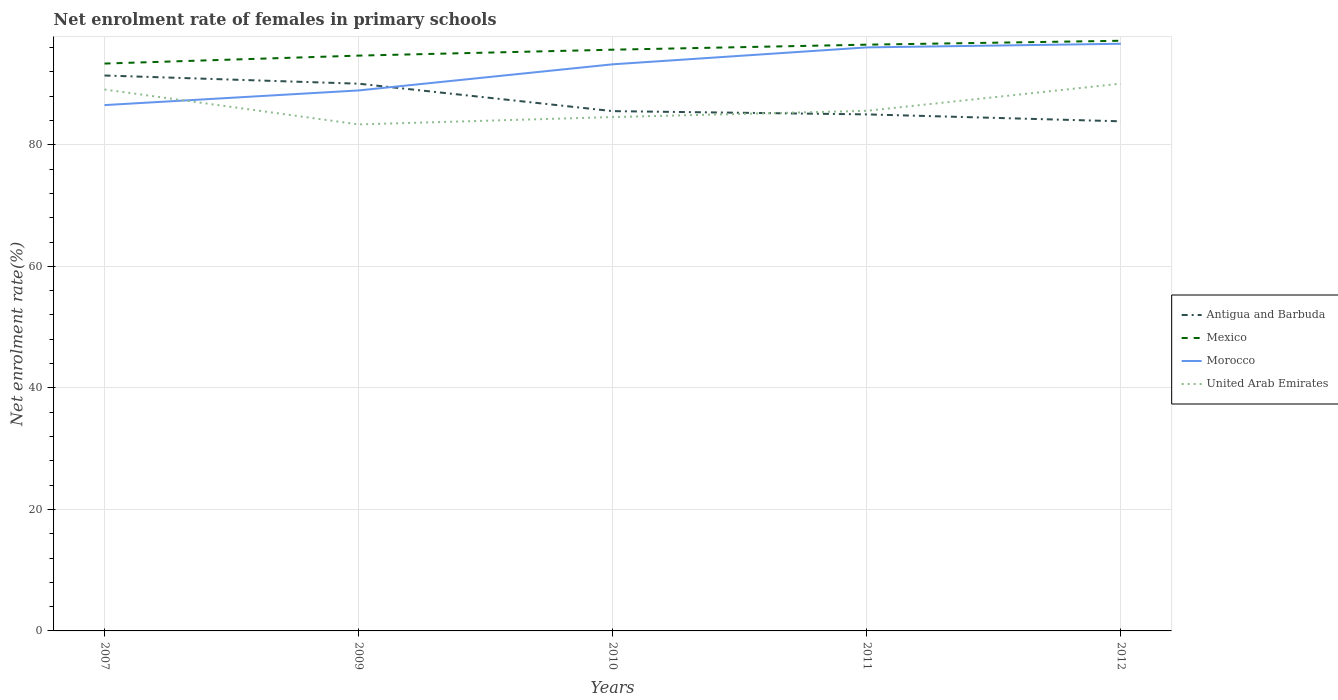How many different coloured lines are there?
Make the answer very short. 4. Does the line corresponding to Morocco intersect with the line corresponding to Mexico?
Keep it short and to the point. No. Is the number of lines equal to the number of legend labels?
Offer a terse response. Yes. Across all years, what is the maximum net enrolment rate of females in primary schools in Antigua and Barbuda?
Give a very brief answer. 83.87. In which year was the net enrolment rate of females in primary schools in United Arab Emirates maximum?
Provide a succinct answer. 2009. What is the total net enrolment rate of females in primary schools in Morocco in the graph?
Your response must be concise. -3.38. What is the difference between the highest and the second highest net enrolment rate of females in primary schools in Morocco?
Your response must be concise. 10.09. What is the difference between the highest and the lowest net enrolment rate of females in primary schools in Morocco?
Provide a short and direct response. 3. Is the net enrolment rate of females in primary schools in Mexico strictly greater than the net enrolment rate of females in primary schools in Antigua and Barbuda over the years?
Offer a terse response. No. How many lines are there?
Keep it short and to the point. 4. How many years are there in the graph?
Your answer should be compact. 5. What is the difference between two consecutive major ticks on the Y-axis?
Give a very brief answer. 20. Are the values on the major ticks of Y-axis written in scientific E-notation?
Your response must be concise. No. Does the graph contain grids?
Your answer should be very brief. Yes. Where does the legend appear in the graph?
Provide a short and direct response. Center right. How many legend labels are there?
Offer a terse response. 4. What is the title of the graph?
Your answer should be compact. Net enrolment rate of females in primary schools. Does "Serbia" appear as one of the legend labels in the graph?
Ensure brevity in your answer.  No. What is the label or title of the Y-axis?
Ensure brevity in your answer.  Net enrolment rate(%). What is the Net enrolment rate(%) in Antigua and Barbuda in 2007?
Provide a succinct answer. 91.42. What is the Net enrolment rate(%) of Mexico in 2007?
Provide a succinct answer. 93.38. What is the Net enrolment rate(%) in Morocco in 2007?
Keep it short and to the point. 86.54. What is the Net enrolment rate(%) of United Arab Emirates in 2007?
Give a very brief answer. 89.11. What is the Net enrolment rate(%) in Antigua and Barbuda in 2009?
Provide a short and direct response. 90.07. What is the Net enrolment rate(%) of Mexico in 2009?
Offer a very short reply. 94.69. What is the Net enrolment rate(%) of Morocco in 2009?
Your answer should be compact. 88.96. What is the Net enrolment rate(%) in United Arab Emirates in 2009?
Provide a succinct answer. 83.37. What is the Net enrolment rate(%) in Antigua and Barbuda in 2010?
Provide a succinct answer. 85.55. What is the Net enrolment rate(%) in Mexico in 2010?
Make the answer very short. 95.66. What is the Net enrolment rate(%) in Morocco in 2010?
Make the answer very short. 93.26. What is the Net enrolment rate(%) in United Arab Emirates in 2010?
Offer a very short reply. 84.57. What is the Net enrolment rate(%) of Antigua and Barbuda in 2011?
Provide a succinct answer. 85.01. What is the Net enrolment rate(%) in Mexico in 2011?
Provide a short and direct response. 96.49. What is the Net enrolment rate(%) in Morocco in 2011?
Make the answer very short. 96.04. What is the Net enrolment rate(%) of United Arab Emirates in 2011?
Your answer should be compact. 85.6. What is the Net enrolment rate(%) of Antigua and Barbuda in 2012?
Keep it short and to the point. 83.87. What is the Net enrolment rate(%) of Mexico in 2012?
Offer a terse response. 97.13. What is the Net enrolment rate(%) in Morocco in 2012?
Your answer should be very brief. 96.64. What is the Net enrolment rate(%) in United Arab Emirates in 2012?
Your answer should be very brief. 90.07. Across all years, what is the maximum Net enrolment rate(%) in Antigua and Barbuda?
Keep it short and to the point. 91.42. Across all years, what is the maximum Net enrolment rate(%) in Mexico?
Ensure brevity in your answer.  97.13. Across all years, what is the maximum Net enrolment rate(%) in Morocco?
Keep it short and to the point. 96.64. Across all years, what is the maximum Net enrolment rate(%) of United Arab Emirates?
Your response must be concise. 90.07. Across all years, what is the minimum Net enrolment rate(%) of Antigua and Barbuda?
Offer a terse response. 83.87. Across all years, what is the minimum Net enrolment rate(%) of Mexico?
Your answer should be compact. 93.38. Across all years, what is the minimum Net enrolment rate(%) of Morocco?
Your response must be concise. 86.54. Across all years, what is the minimum Net enrolment rate(%) of United Arab Emirates?
Your answer should be compact. 83.37. What is the total Net enrolment rate(%) in Antigua and Barbuda in the graph?
Provide a succinct answer. 435.92. What is the total Net enrolment rate(%) in Mexico in the graph?
Keep it short and to the point. 477.35. What is the total Net enrolment rate(%) in Morocco in the graph?
Make the answer very short. 461.43. What is the total Net enrolment rate(%) of United Arab Emirates in the graph?
Your response must be concise. 432.72. What is the difference between the Net enrolment rate(%) of Antigua and Barbuda in 2007 and that in 2009?
Give a very brief answer. 1.35. What is the difference between the Net enrolment rate(%) in Mexico in 2007 and that in 2009?
Give a very brief answer. -1.31. What is the difference between the Net enrolment rate(%) of Morocco in 2007 and that in 2009?
Give a very brief answer. -2.41. What is the difference between the Net enrolment rate(%) in United Arab Emirates in 2007 and that in 2009?
Your answer should be very brief. 5.74. What is the difference between the Net enrolment rate(%) in Antigua and Barbuda in 2007 and that in 2010?
Give a very brief answer. 5.87. What is the difference between the Net enrolment rate(%) in Mexico in 2007 and that in 2010?
Provide a succinct answer. -2.28. What is the difference between the Net enrolment rate(%) of Morocco in 2007 and that in 2010?
Provide a short and direct response. -6.71. What is the difference between the Net enrolment rate(%) of United Arab Emirates in 2007 and that in 2010?
Offer a very short reply. 4.54. What is the difference between the Net enrolment rate(%) in Antigua and Barbuda in 2007 and that in 2011?
Keep it short and to the point. 6.4. What is the difference between the Net enrolment rate(%) of Mexico in 2007 and that in 2011?
Provide a short and direct response. -3.11. What is the difference between the Net enrolment rate(%) of Morocco in 2007 and that in 2011?
Keep it short and to the point. -9.5. What is the difference between the Net enrolment rate(%) in United Arab Emirates in 2007 and that in 2011?
Offer a terse response. 3.5. What is the difference between the Net enrolment rate(%) in Antigua and Barbuda in 2007 and that in 2012?
Give a very brief answer. 7.54. What is the difference between the Net enrolment rate(%) of Mexico in 2007 and that in 2012?
Provide a short and direct response. -3.75. What is the difference between the Net enrolment rate(%) in Morocco in 2007 and that in 2012?
Ensure brevity in your answer.  -10.09. What is the difference between the Net enrolment rate(%) of United Arab Emirates in 2007 and that in 2012?
Your answer should be compact. -0.96. What is the difference between the Net enrolment rate(%) in Antigua and Barbuda in 2009 and that in 2010?
Provide a short and direct response. 4.52. What is the difference between the Net enrolment rate(%) of Mexico in 2009 and that in 2010?
Provide a succinct answer. -0.97. What is the difference between the Net enrolment rate(%) in United Arab Emirates in 2009 and that in 2010?
Your answer should be very brief. -1.21. What is the difference between the Net enrolment rate(%) in Antigua and Barbuda in 2009 and that in 2011?
Offer a very short reply. 5.05. What is the difference between the Net enrolment rate(%) of Mexico in 2009 and that in 2011?
Offer a terse response. -1.8. What is the difference between the Net enrolment rate(%) of Morocco in 2009 and that in 2011?
Give a very brief answer. -7.09. What is the difference between the Net enrolment rate(%) of United Arab Emirates in 2009 and that in 2011?
Keep it short and to the point. -2.24. What is the difference between the Net enrolment rate(%) in Antigua and Barbuda in 2009 and that in 2012?
Offer a terse response. 6.19. What is the difference between the Net enrolment rate(%) of Mexico in 2009 and that in 2012?
Your answer should be very brief. -2.44. What is the difference between the Net enrolment rate(%) of Morocco in 2009 and that in 2012?
Ensure brevity in your answer.  -7.68. What is the difference between the Net enrolment rate(%) of United Arab Emirates in 2009 and that in 2012?
Offer a terse response. -6.7. What is the difference between the Net enrolment rate(%) in Antigua and Barbuda in 2010 and that in 2011?
Provide a short and direct response. 0.54. What is the difference between the Net enrolment rate(%) in Mexico in 2010 and that in 2011?
Ensure brevity in your answer.  -0.83. What is the difference between the Net enrolment rate(%) in Morocco in 2010 and that in 2011?
Your response must be concise. -2.79. What is the difference between the Net enrolment rate(%) in United Arab Emirates in 2010 and that in 2011?
Your answer should be compact. -1.03. What is the difference between the Net enrolment rate(%) of Antigua and Barbuda in 2010 and that in 2012?
Ensure brevity in your answer.  1.68. What is the difference between the Net enrolment rate(%) in Mexico in 2010 and that in 2012?
Provide a short and direct response. -1.47. What is the difference between the Net enrolment rate(%) of Morocco in 2010 and that in 2012?
Offer a very short reply. -3.38. What is the difference between the Net enrolment rate(%) of United Arab Emirates in 2010 and that in 2012?
Ensure brevity in your answer.  -5.5. What is the difference between the Net enrolment rate(%) in Antigua and Barbuda in 2011 and that in 2012?
Your answer should be very brief. 1.14. What is the difference between the Net enrolment rate(%) in Mexico in 2011 and that in 2012?
Your answer should be very brief. -0.64. What is the difference between the Net enrolment rate(%) of Morocco in 2011 and that in 2012?
Offer a terse response. -0.6. What is the difference between the Net enrolment rate(%) in United Arab Emirates in 2011 and that in 2012?
Ensure brevity in your answer.  -4.47. What is the difference between the Net enrolment rate(%) of Antigua and Barbuda in 2007 and the Net enrolment rate(%) of Mexico in 2009?
Give a very brief answer. -3.27. What is the difference between the Net enrolment rate(%) in Antigua and Barbuda in 2007 and the Net enrolment rate(%) in Morocco in 2009?
Ensure brevity in your answer.  2.46. What is the difference between the Net enrolment rate(%) in Antigua and Barbuda in 2007 and the Net enrolment rate(%) in United Arab Emirates in 2009?
Give a very brief answer. 8.05. What is the difference between the Net enrolment rate(%) in Mexico in 2007 and the Net enrolment rate(%) in Morocco in 2009?
Provide a succinct answer. 4.42. What is the difference between the Net enrolment rate(%) in Mexico in 2007 and the Net enrolment rate(%) in United Arab Emirates in 2009?
Give a very brief answer. 10.01. What is the difference between the Net enrolment rate(%) of Morocco in 2007 and the Net enrolment rate(%) of United Arab Emirates in 2009?
Provide a succinct answer. 3.18. What is the difference between the Net enrolment rate(%) of Antigua and Barbuda in 2007 and the Net enrolment rate(%) of Mexico in 2010?
Provide a short and direct response. -4.25. What is the difference between the Net enrolment rate(%) in Antigua and Barbuda in 2007 and the Net enrolment rate(%) in Morocco in 2010?
Your response must be concise. -1.84. What is the difference between the Net enrolment rate(%) in Antigua and Barbuda in 2007 and the Net enrolment rate(%) in United Arab Emirates in 2010?
Keep it short and to the point. 6.84. What is the difference between the Net enrolment rate(%) in Mexico in 2007 and the Net enrolment rate(%) in Morocco in 2010?
Provide a succinct answer. 0.12. What is the difference between the Net enrolment rate(%) in Mexico in 2007 and the Net enrolment rate(%) in United Arab Emirates in 2010?
Offer a very short reply. 8.81. What is the difference between the Net enrolment rate(%) of Morocco in 2007 and the Net enrolment rate(%) of United Arab Emirates in 2010?
Provide a succinct answer. 1.97. What is the difference between the Net enrolment rate(%) in Antigua and Barbuda in 2007 and the Net enrolment rate(%) in Mexico in 2011?
Offer a very short reply. -5.07. What is the difference between the Net enrolment rate(%) in Antigua and Barbuda in 2007 and the Net enrolment rate(%) in Morocco in 2011?
Provide a short and direct response. -4.63. What is the difference between the Net enrolment rate(%) of Antigua and Barbuda in 2007 and the Net enrolment rate(%) of United Arab Emirates in 2011?
Offer a terse response. 5.81. What is the difference between the Net enrolment rate(%) of Mexico in 2007 and the Net enrolment rate(%) of Morocco in 2011?
Your answer should be very brief. -2.66. What is the difference between the Net enrolment rate(%) of Mexico in 2007 and the Net enrolment rate(%) of United Arab Emirates in 2011?
Your answer should be compact. 7.77. What is the difference between the Net enrolment rate(%) of Morocco in 2007 and the Net enrolment rate(%) of United Arab Emirates in 2011?
Offer a very short reply. 0.94. What is the difference between the Net enrolment rate(%) in Antigua and Barbuda in 2007 and the Net enrolment rate(%) in Mexico in 2012?
Provide a succinct answer. -5.72. What is the difference between the Net enrolment rate(%) of Antigua and Barbuda in 2007 and the Net enrolment rate(%) of Morocco in 2012?
Offer a terse response. -5.22. What is the difference between the Net enrolment rate(%) in Antigua and Barbuda in 2007 and the Net enrolment rate(%) in United Arab Emirates in 2012?
Provide a short and direct response. 1.34. What is the difference between the Net enrolment rate(%) of Mexico in 2007 and the Net enrolment rate(%) of Morocco in 2012?
Make the answer very short. -3.26. What is the difference between the Net enrolment rate(%) of Mexico in 2007 and the Net enrolment rate(%) of United Arab Emirates in 2012?
Make the answer very short. 3.31. What is the difference between the Net enrolment rate(%) of Morocco in 2007 and the Net enrolment rate(%) of United Arab Emirates in 2012?
Your answer should be compact. -3.53. What is the difference between the Net enrolment rate(%) in Antigua and Barbuda in 2009 and the Net enrolment rate(%) in Mexico in 2010?
Keep it short and to the point. -5.6. What is the difference between the Net enrolment rate(%) in Antigua and Barbuda in 2009 and the Net enrolment rate(%) in Morocco in 2010?
Your response must be concise. -3.19. What is the difference between the Net enrolment rate(%) of Antigua and Barbuda in 2009 and the Net enrolment rate(%) of United Arab Emirates in 2010?
Make the answer very short. 5.49. What is the difference between the Net enrolment rate(%) of Mexico in 2009 and the Net enrolment rate(%) of Morocco in 2010?
Ensure brevity in your answer.  1.43. What is the difference between the Net enrolment rate(%) in Mexico in 2009 and the Net enrolment rate(%) in United Arab Emirates in 2010?
Provide a succinct answer. 10.12. What is the difference between the Net enrolment rate(%) in Morocco in 2009 and the Net enrolment rate(%) in United Arab Emirates in 2010?
Your answer should be compact. 4.38. What is the difference between the Net enrolment rate(%) in Antigua and Barbuda in 2009 and the Net enrolment rate(%) in Mexico in 2011?
Provide a succinct answer. -6.42. What is the difference between the Net enrolment rate(%) in Antigua and Barbuda in 2009 and the Net enrolment rate(%) in Morocco in 2011?
Provide a succinct answer. -5.98. What is the difference between the Net enrolment rate(%) in Antigua and Barbuda in 2009 and the Net enrolment rate(%) in United Arab Emirates in 2011?
Your answer should be very brief. 4.46. What is the difference between the Net enrolment rate(%) in Mexico in 2009 and the Net enrolment rate(%) in Morocco in 2011?
Make the answer very short. -1.35. What is the difference between the Net enrolment rate(%) of Mexico in 2009 and the Net enrolment rate(%) of United Arab Emirates in 2011?
Provide a short and direct response. 9.08. What is the difference between the Net enrolment rate(%) of Morocco in 2009 and the Net enrolment rate(%) of United Arab Emirates in 2011?
Provide a short and direct response. 3.35. What is the difference between the Net enrolment rate(%) of Antigua and Barbuda in 2009 and the Net enrolment rate(%) of Mexico in 2012?
Offer a terse response. -7.07. What is the difference between the Net enrolment rate(%) of Antigua and Barbuda in 2009 and the Net enrolment rate(%) of Morocco in 2012?
Keep it short and to the point. -6.57. What is the difference between the Net enrolment rate(%) in Antigua and Barbuda in 2009 and the Net enrolment rate(%) in United Arab Emirates in 2012?
Keep it short and to the point. -0. What is the difference between the Net enrolment rate(%) of Mexico in 2009 and the Net enrolment rate(%) of Morocco in 2012?
Your answer should be compact. -1.95. What is the difference between the Net enrolment rate(%) of Mexico in 2009 and the Net enrolment rate(%) of United Arab Emirates in 2012?
Provide a succinct answer. 4.62. What is the difference between the Net enrolment rate(%) in Morocco in 2009 and the Net enrolment rate(%) in United Arab Emirates in 2012?
Give a very brief answer. -1.11. What is the difference between the Net enrolment rate(%) in Antigua and Barbuda in 2010 and the Net enrolment rate(%) in Mexico in 2011?
Ensure brevity in your answer.  -10.94. What is the difference between the Net enrolment rate(%) of Antigua and Barbuda in 2010 and the Net enrolment rate(%) of Morocco in 2011?
Provide a succinct answer. -10.49. What is the difference between the Net enrolment rate(%) of Antigua and Barbuda in 2010 and the Net enrolment rate(%) of United Arab Emirates in 2011?
Keep it short and to the point. -0.05. What is the difference between the Net enrolment rate(%) in Mexico in 2010 and the Net enrolment rate(%) in Morocco in 2011?
Provide a short and direct response. -0.38. What is the difference between the Net enrolment rate(%) of Mexico in 2010 and the Net enrolment rate(%) of United Arab Emirates in 2011?
Keep it short and to the point. 10.06. What is the difference between the Net enrolment rate(%) in Morocco in 2010 and the Net enrolment rate(%) in United Arab Emirates in 2011?
Provide a succinct answer. 7.65. What is the difference between the Net enrolment rate(%) of Antigua and Barbuda in 2010 and the Net enrolment rate(%) of Mexico in 2012?
Keep it short and to the point. -11.58. What is the difference between the Net enrolment rate(%) of Antigua and Barbuda in 2010 and the Net enrolment rate(%) of Morocco in 2012?
Keep it short and to the point. -11.09. What is the difference between the Net enrolment rate(%) in Antigua and Barbuda in 2010 and the Net enrolment rate(%) in United Arab Emirates in 2012?
Offer a terse response. -4.52. What is the difference between the Net enrolment rate(%) of Mexico in 2010 and the Net enrolment rate(%) of Morocco in 2012?
Offer a terse response. -0.98. What is the difference between the Net enrolment rate(%) of Mexico in 2010 and the Net enrolment rate(%) of United Arab Emirates in 2012?
Keep it short and to the point. 5.59. What is the difference between the Net enrolment rate(%) in Morocco in 2010 and the Net enrolment rate(%) in United Arab Emirates in 2012?
Your answer should be very brief. 3.19. What is the difference between the Net enrolment rate(%) of Antigua and Barbuda in 2011 and the Net enrolment rate(%) of Mexico in 2012?
Your answer should be very brief. -12.12. What is the difference between the Net enrolment rate(%) in Antigua and Barbuda in 2011 and the Net enrolment rate(%) in Morocco in 2012?
Keep it short and to the point. -11.62. What is the difference between the Net enrolment rate(%) in Antigua and Barbuda in 2011 and the Net enrolment rate(%) in United Arab Emirates in 2012?
Your answer should be compact. -5.06. What is the difference between the Net enrolment rate(%) of Mexico in 2011 and the Net enrolment rate(%) of Morocco in 2012?
Your answer should be very brief. -0.15. What is the difference between the Net enrolment rate(%) of Mexico in 2011 and the Net enrolment rate(%) of United Arab Emirates in 2012?
Your response must be concise. 6.42. What is the difference between the Net enrolment rate(%) in Morocco in 2011 and the Net enrolment rate(%) in United Arab Emirates in 2012?
Provide a short and direct response. 5.97. What is the average Net enrolment rate(%) of Antigua and Barbuda per year?
Give a very brief answer. 87.18. What is the average Net enrolment rate(%) in Mexico per year?
Offer a very short reply. 95.47. What is the average Net enrolment rate(%) of Morocco per year?
Keep it short and to the point. 92.29. What is the average Net enrolment rate(%) in United Arab Emirates per year?
Give a very brief answer. 86.54. In the year 2007, what is the difference between the Net enrolment rate(%) of Antigua and Barbuda and Net enrolment rate(%) of Mexico?
Offer a very short reply. -1.96. In the year 2007, what is the difference between the Net enrolment rate(%) in Antigua and Barbuda and Net enrolment rate(%) in Morocco?
Offer a terse response. 4.87. In the year 2007, what is the difference between the Net enrolment rate(%) of Antigua and Barbuda and Net enrolment rate(%) of United Arab Emirates?
Offer a very short reply. 2.31. In the year 2007, what is the difference between the Net enrolment rate(%) of Mexico and Net enrolment rate(%) of Morocco?
Give a very brief answer. 6.83. In the year 2007, what is the difference between the Net enrolment rate(%) of Mexico and Net enrolment rate(%) of United Arab Emirates?
Your answer should be compact. 4.27. In the year 2007, what is the difference between the Net enrolment rate(%) in Morocco and Net enrolment rate(%) in United Arab Emirates?
Your response must be concise. -2.56. In the year 2009, what is the difference between the Net enrolment rate(%) of Antigua and Barbuda and Net enrolment rate(%) of Mexico?
Give a very brief answer. -4.62. In the year 2009, what is the difference between the Net enrolment rate(%) of Antigua and Barbuda and Net enrolment rate(%) of Morocco?
Offer a very short reply. 1.11. In the year 2009, what is the difference between the Net enrolment rate(%) of Antigua and Barbuda and Net enrolment rate(%) of United Arab Emirates?
Your answer should be very brief. 6.7. In the year 2009, what is the difference between the Net enrolment rate(%) of Mexico and Net enrolment rate(%) of Morocco?
Your answer should be compact. 5.73. In the year 2009, what is the difference between the Net enrolment rate(%) of Mexico and Net enrolment rate(%) of United Arab Emirates?
Provide a short and direct response. 11.32. In the year 2009, what is the difference between the Net enrolment rate(%) of Morocco and Net enrolment rate(%) of United Arab Emirates?
Your response must be concise. 5.59. In the year 2010, what is the difference between the Net enrolment rate(%) in Antigua and Barbuda and Net enrolment rate(%) in Mexico?
Offer a very short reply. -10.11. In the year 2010, what is the difference between the Net enrolment rate(%) of Antigua and Barbuda and Net enrolment rate(%) of Morocco?
Keep it short and to the point. -7.71. In the year 2010, what is the difference between the Net enrolment rate(%) in Antigua and Barbuda and Net enrolment rate(%) in United Arab Emirates?
Your response must be concise. 0.98. In the year 2010, what is the difference between the Net enrolment rate(%) in Mexico and Net enrolment rate(%) in Morocco?
Your response must be concise. 2.41. In the year 2010, what is the difference between the Net enrolment rate(%) of Mexico and Net enrolment rate(%) of United Arab Emirates?
Offer a very short reply. 11.09. In the year 2010, what is the difference between the Net enrolment rate(%) of Morocco and Net enrolment rate(%) of United Arab Emirates?
Offer a terse response. 8.68. In the year 2011, what is the difference between the Net enrolment rate(%) in Antigua and Barbuda and Net enrolment rate(%) in Mexico?
Provide a short and direct response. -11.48. In the year 2011, what is the difference between the Net enrolment rate(%) in Antigua and Barbuda and Net enrolment rate(%) in Morocco?
Offer a very short reply. -11.03. In the year 2011, what is the difference between the Net enrolment rate(%) in Antigua and Barbuda and Net enrolment rate(%) in United Arab Emirates?
Provide a succinct answer. -0.59. In the year 2011, what is the difference between the Net enrolment rate(%) of Mexico and Net enrolment rate(%) of Morocco?
Your answer should be very brief. 0.45. In the year 2011, what is the difference between the Net enrolment rate(%) in Mexico and Net enrolment rate(%) in United Arab Emirates?
Your response must be concise. 10.88. In the year 2011, what is the difference between the Net enrolment rate(%) of Morocco and Net enrolment rate(%) of United Arab Emirates?
Provide a succinct answer. 10.44. In the year 2012, what is the difference between the Net enrolment rate(%) of Antigua and Barbuda and Net enrolment rate(%) of Mexico?
Offer a terse response. -13.26. In the year 2012, what is the difference between the Net enrolment rate(%) in Antigua and Barbuda and Net enrolment rate(%) in Morocco?
Your response must be concise. -12.76. In the year 2012, what is the difference between the Net enrolment rate(%) of Antigua and Barbuda and Net enrolment rate(%) of United Arab Emirates?
Offer a very short reply. -6.2. In the year 2012, what is the difference between the Net enrolment rate(%) in Mexico and Net enrolment rate(%) in Morocco?
Offer a very short reply. 0.5. In the year 2012, what is the difference between the Net enrolment rate(%) of Mexico and Net enrolment rate(%) of United Arab Emirates?
Make the answer very short. 7.06. In the year 2012, what is the difference between the Net enrolment rate(%) of Morocco and Net enrolment rate(%) of United Arab Emirates?
Keep it short and to the point. 6.57. What is the ratio of the Net enrolment rate(%) in Mexico in 2007 to that in 2009?
Your answer should be compact. 0.99. What is the ratio of the Net enrolment rate(%) in Morocco in 2007 to that in 2009?
Provide a short and direct response. 0.97. What is the ratio of the Net enrolment rate(%) of United Arab Emirates in 2007 to that in 2009?
Your response must be concise. 1.07. What is the ratio of the Net enrolment rate(%) of Antigua and Barbuda in 2007 to that in 2010?
Keep it short and to the point. 1.07. What is the ratio of the Net enrolment rate(%) in Mexico in 2007 to that in 2010?
Your answer should be compact. 0.98. What is the ratio of the Net enrolment rate(%) of Morocco in 2007 to that in 2010?
Keep it short and to the point. 0.93. What is the ratio of the Net enrolment rate(%) in United Arab Emirates in 2007 to that in 2010?
Your answer should be very brief. 1.05. What is the ratio of the Net enrolment rate(%) in Antigua and Barbuda in 2007 to that in 2011?
Give a very brief answer. 1.08. What is the ratio of the Net enrolment rate(%) in Mexico in 2007 to that in 2011?
Your answer should be very brief. 0.97. What is the ratio of the Net enrolment rate(%) in Morocco in 2007 to that in 2011?
Make the answer very short. 0.9. What is the ratio of the Net enrolment rate(%) of United Arab Emirates in 2007 to that in 2011?
Provide a succinct answer. 1.04. What is the ratio of the Net enrolment rate(%) of Antigua and Barbuda in 2007 to that in 2012?
Your response must be concise. 1.09. What is the ratio of the Net enrolment rate(%) of Mexico in 2007 to that in 2012?
Your response must be concise. 0.96. What is the ratio of the Net enrolment rate(%) of Morocco in 2007 to that in 2012?
Make the answer very short. 0.9. What is the ratio of the Net enrolment rate(%) of United Arab Emirates in 2007 to that in 2012?
Your response must be concise. 0.99. What is the ratio of the Net enrolment rate(%) in Antigua and Barbuda in 2009 to that in 2010?
Provide a succinct answer. 1.05. What is the ratio of the Net enrolment rate(%) of Morocco in 2009 to that in 2010?
Offer a very short reply. 0.95. What is the ratio of the Net enrolment rate(%) in United Arab Emirates in 2009 to that in 2010?
Your answer should be very brief. 0.99. What is the ratio of the Net enrolment rate(%) in Antigua and Barbuda in 2009 to that in 2011?
Keep it short and to the point. 1.06. What is the ratio of the Net enrolment rate(%) in Mexico in 2009 to that in 2011?
Ensure brevity in your answer.  0.98. What is the ratio of the Net enrolment rate(%) in Morocco in 2009 to that in 2011?
Provide a short and direct response. 0.93. What is the ratio of the Net enrolment rate(%) in United Arab Emirates in 2009 to that in 2011?
Your answer should be compact. 0.97. What is the ratio of the Net enrolment rate(%) of Antigua and Barbuda in 2009 to that in 2012?
Your answer should be very brief. 1.07. What is the ratio of the Net enrolment rate(%) in Mexico in 2009 to that in 2012?
Your response must be concise. 0.97. What is the ratio of the Net enrolment rate(%) in Morocco in 2009 to that in 2012?
Give a very brief answer. 0.92. What is the ratio of the Net enrolment rate(%) of United Arab Emirates in 2009 to that in 2012?
Offer a terse response. 0.93. What is the ratio of the Net enrolment rate(%) in Antigua and Barbuda in 2010 to that in 2011?
Give a very brief answer. 1.01. What is the ratio of the Net enrolment rate(%) in Mexico in 2010 to that in 2011?
Provide a succinct answer. 0.99. What is the ratio of the Net enrolment rate(%) of United Arab Emirates in 2010 to that in 2011?
Offer a very short reply. 0.99. What is the ratio of the Net enrolment rate(%) in Mexico in 2010 to that in 2012?
Offer a very short reply. 0.98. What is the ratio of the Net enrolment rate(%) in Morocco in 2010 to that in 2012?
Your response must be concise. 0.96. What is the ratio of the Net enrolment rate(%) of United Arab Emirates in 2010 to that in 2012?
Give a very brief answer. 0.94. What is the ratio of the Net enrolment rate(%) in Antigua and Barbuda in 2011 to that in 2012?
Your response must be concise. 1.01. What is the ratio of the Net enrolment rate(%) of United Arab Emirates in 2011 to that in 2012?
Give a very brief answer. 0.95. What is the difference between the highest and the second highest Net enrolment rate(%) of Antigua and Barbuda?
Your answer should be very brief. 1.35. What is the difference between the highest and the second highest Net enrolment rate(%) in Mexico?
Give a very brief answer. 0.64. What is the difference between the highest and the second highest Net enrolment rate(%) in Morocco?
Your answer should be compact. 0.6. What is the difference between the highest and the second highest Net enrolment rate(%) of United Arab Emirates?
Provide a short and direct response. 0.96. What is the difference between the highest and the lowest Net enrolment rate(%) in Antigua and Barbuda?
Keep it short and to the point. 7.54. What is the difference between the highest and the lowest Net enrolment rate(%) in Mexico?
Ensure brevity in your answer.  3.75. What is the difference between the highest and the lowest Net enrolment rate(%) of Morocco?
Make the answer very short. 10.09. What is the difference between the highest and the lowest Net enrolment rate(%) of United Arab Emirates?
Your response must be concise. 6.7. 